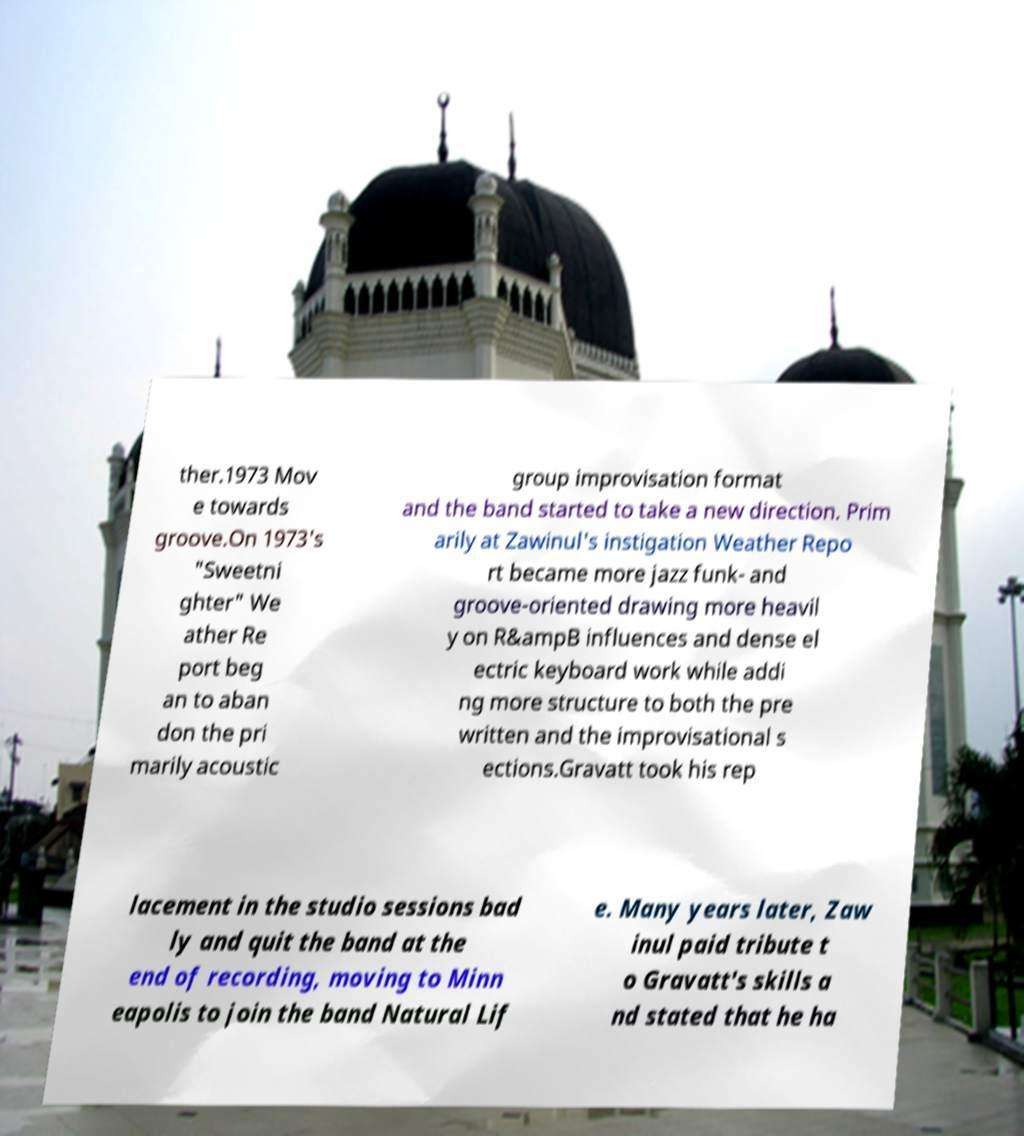Could you extract and type out the text from this image? ther.1973 Mov e towards groove.On 1973's "Sweetni ghter" We ather Re port beg an to aban don the pri marily acoustic group improvisation format and the band started to take a new direction. Prim arily at Zawinul's instigation Weather Repo rt became more jazz funk- and groove-oriented drawing more heavil y on R&ampB influences and dense el ectric keyboard work while addi ng more structure to both the pre written and the improvisational s ections.Gravatt took his rep lacement in the studio sessions bad ly and quit the band at the end of recording, moving to Minn eapolis to join the band Natural Lif e. Many years later, Zaw inul paid tribute t o Gravatt's skills a nd stated that he ha 